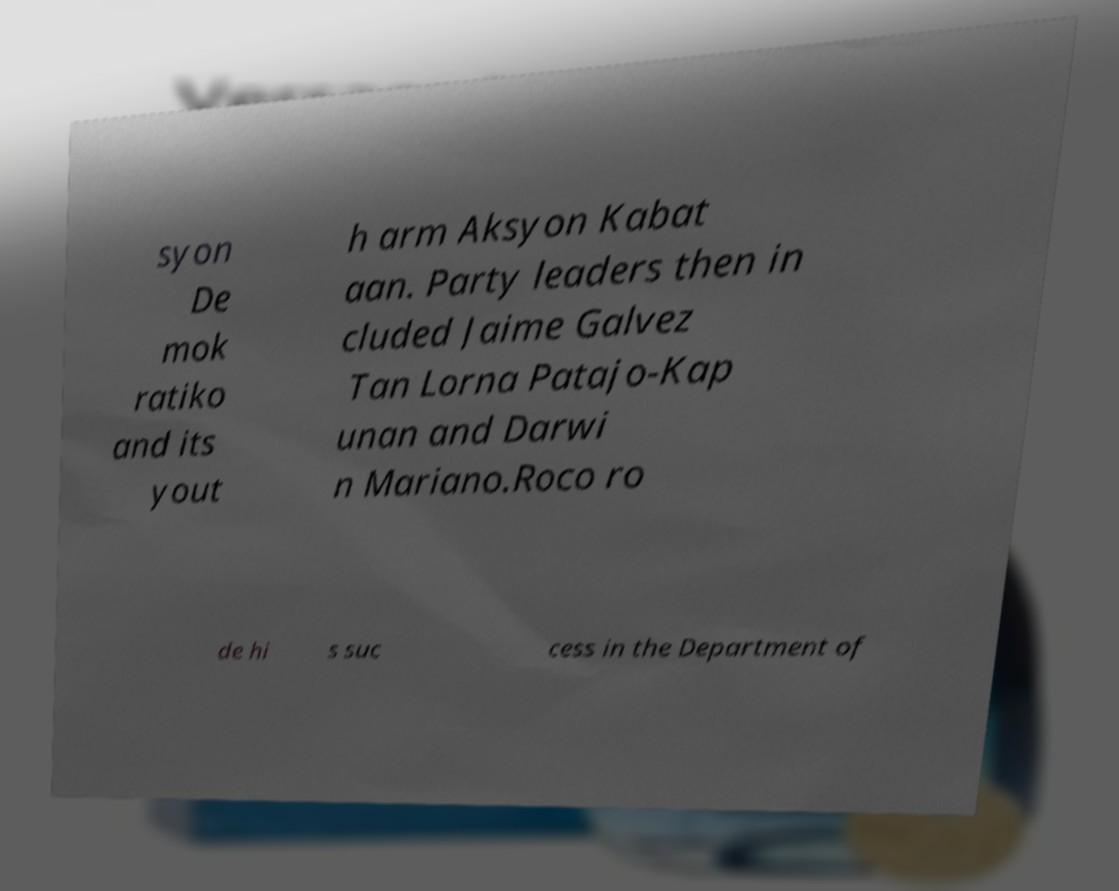What messages or text are displayed in this image? I need them in a readable, typed format. syon De mok ratiko and its yout h arm Aksyon Kabat aan. Party leaders then in cluded Jaime Galvez Tan Lorna Patajo-Kap unan and Darwi n Mariano.Roco ro de hi s suc cess in the Department of 